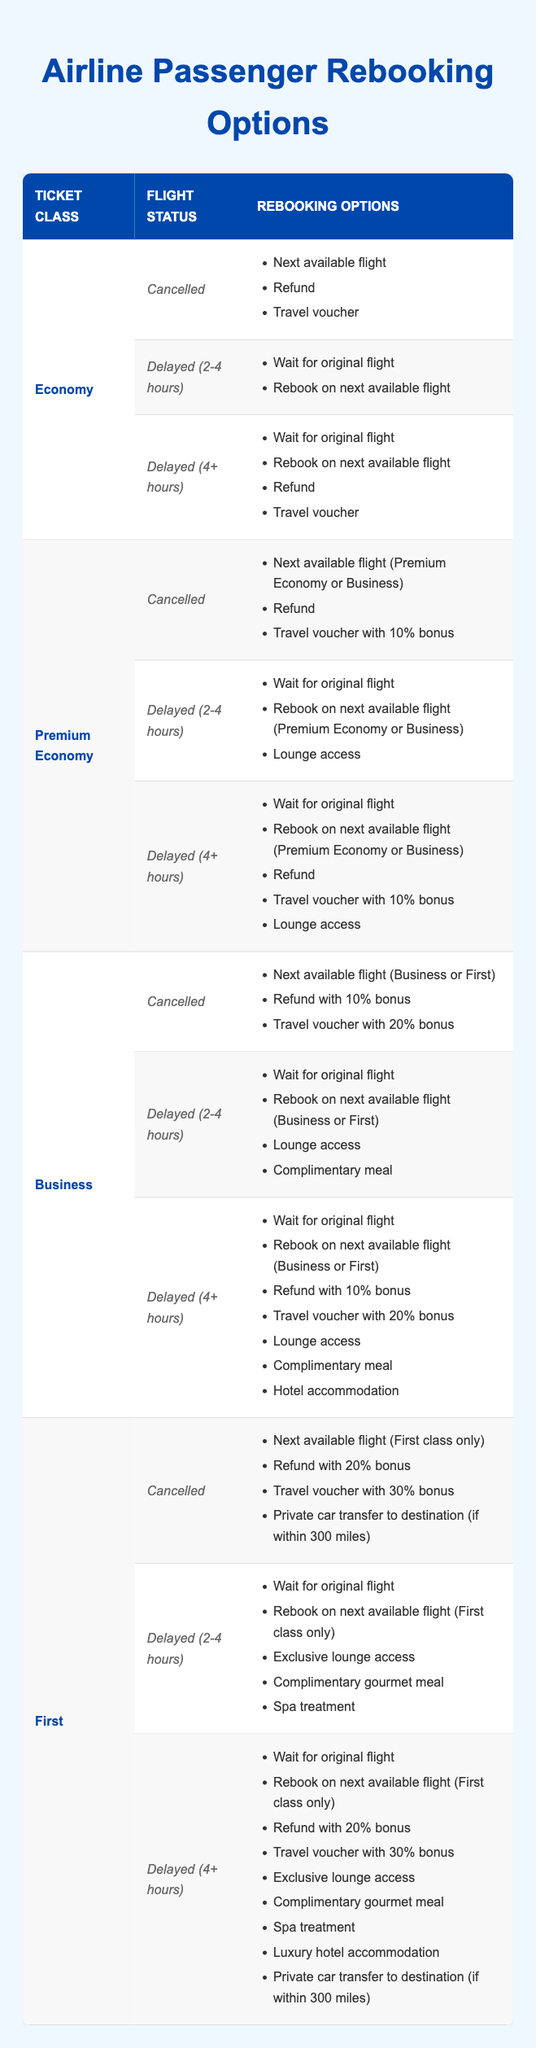What options are available for Economy class passengers if their flight is cancelled? According to the table, if the flight status is "Cancelled" for Economy class, the options are: "Next available flight," "Refund," and "Travel voucher." These options are explicitly listed under the Economy class and Cancelled flight status in the table.
Answer: Next available flight, Refund, Travel voucher If a Premium Economy passenger's flight is delayed for 4 or more hours, what are the options? The table specifies that for the Premium Economy class with a flight status of "Delayed (4+ hours)," the options are: "Wait for original flight," "Rebook on next available flight (Premium Economy or Business)," "Refund," "Travel voucher with 10% bonus," and "Lounge access." These are consolidated from the Premium Economy section corresponding to that flight status.
Answer: Wait for original flight, Rebook on next available flight (Premium Economy or Business), Refund, Travel voucher with 10% bonus, Lounge access Is it true that Business class passengers can receive a refund with a bonus if their flight is delayed for 4 or more hours? In the table, under the Business class for the "Delayed (4+ hours)" status, the option "Refund with 10% bonus" is present. Therefore, it is true that Business class passengers have this option under those conditions.
Answer: Yes How many rebooking options does a First class passenger have if their flight is delayed for 2 to 4 hours? The table lists the options for First class passengers with a flight status of "Delayed (2-4 hours)" as follows: "Wait for original flight," "Rebook on next available flight (First class only)," "Exclusive lounge access," "Complimentary gourmet meal," and "Spa treatment." There are a total of 5 options available.
Answer: 5 Can an Economy class passenger choose a travel voucher if their flight is only delayed for 2-4 hours? The table shows that for Economy class passengers with a flight status of "Delayed (2-4 hours)," the options are "Wait for original flight" and "Rebook on next available flight." There is no mention of a travel voucher for this specific status, indicating this option is not available.
Answer: No If we compare rebooking options for cancelled flights across all classes, which class has the highest number of options? By analyzing the data, the rebooking options for cancelled flights are as follows: Economy has 3 options, Premium Economy has 3 options (including a 10% voucher), Business has 3 options (with a bonus), and First class has 4 options (including a 30% voucher and car transfer). First class has the highest number with 4 options.
Answer: First class What options do passengers in Business class have if their flight is cancelled? According to the table for Business class when a flight is "Cancelled," the options are: "Next available flight (Business or First)," "Refund with 10% bonus," and "Travel voucher with 20% bonus." This accounts for all options available specifically under this flight status for Business class.
Answer: Next available flight (Business or First), Refund with 10% bonus, Travel voucher with 20% bonus Are Business class passengers offered hotel accommodation if their flight is cancelled? The table indicates that for Business class passengers with a "Cancelled" flight status, hotel accommodation is not an option available. The rebooking options listed do not include that choice for a cancelled flight.
Answer: No 